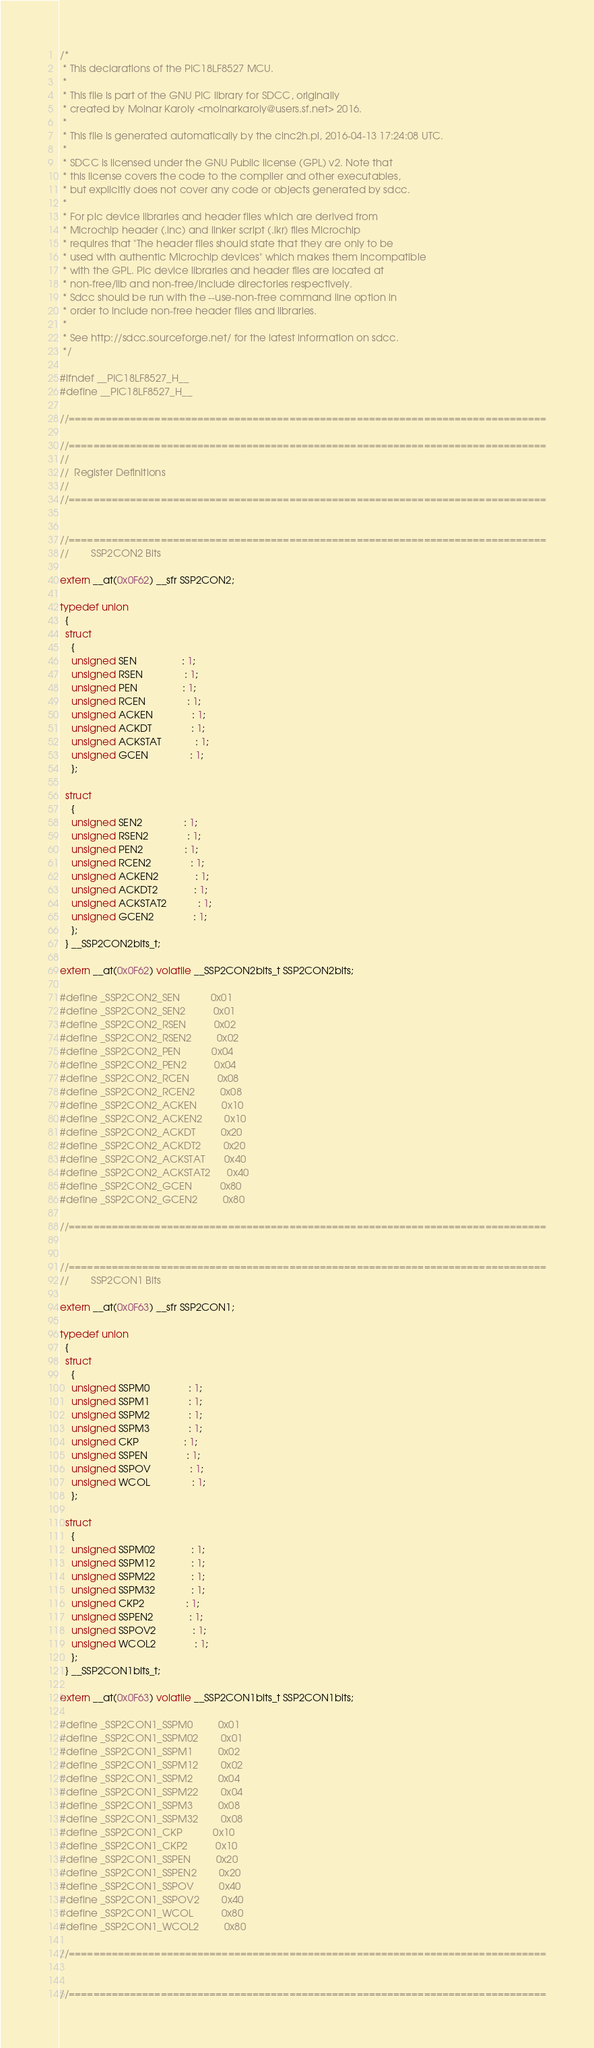Convert code to text. <code><loc_0><loc_0><loc_500><loc_500><_C_>/*
 * This declarations of the PIC18LF8527 MCU.
 *
 * This file is part of the GNU PIC library for SDCC, originally
 * created by Molnar Karoly <molnarkaroly@users.sf.net> 2016.
 *
 * This file is generated automatically by the cinc2h.pl, 2016-04-13 17:24:08 UTC.
 *
 * SDCC is licensed under the GNU Public license (GPL) v2. Note that
 * this license covers the code to the compiler and other executables,
 * but explicitly does not cover any code or objects generated by sdcc.
 *
 * For pic device libraries and header files which are derived from
 * Microchip header (.inc) and linker script (.lkr) files Microchip
 * requires that "The header files should state that they are only to be
 * used with authentic Microchip devices" which makes them incompatible
 * with the GPL. Pic device libraries and header files are located at
 * non-free/lib and non-free/include directories respectively.
 * Sdcc should be run with the --use-non-free command line option in
 * order to include non-free header files and libraries.
 *
 * See http://sdcc.sourceforge.net/ for the latest information on sdcc.
 */

#ifndef __PIC18LF8527_H__
#define __PIC18LF8527_H__

//==============================================================================

//==============================================================================
//
//	Register Definitions
//
//==============================================================================


//==============================================================================
//        SSP2CON2 Bits

extern __at(0x0F62) __sfr SSP2CON2;

typedef union
  {
  struct
    {
    unsigned SEN                : 1;
    unsigned RSEN               : 1;
    unsigned PEN                : 1;
    unsigned RCEN               : 1;
    unsigned ACKEN              : 1;
    unsigned ACKDT              : 1;
    unsigned ACKSTAT            : 1;
    unsigned GCEN               : 1;
    };

  struct
    {
    unsigned SEN2               : 1;
    unsigned RSEN2              : 1;
    unsigned PEN2               : 1;
    unsigned RCEN2              : 1;
    unsigned ACKEN2             : 1;
    unsigned ACKDT2             : 1;
    unsigned ACKSTAT2           : 1;
    unsigned GCEN2              : 1;
    };
  } __SSP2CON2bits_t;

extern __at(0x0F62) volatile __SSP2CON2bits_t SSP2CON2bits;

#define _SSP2CON2_SEN           0x01
#define _SSP2CON2_SEN2          0x01
#define _SSP2CON2_RSEN          0x02
#define _SSP2CON2_RSEN2         0x02
#define _SSP2CON2_PEN           0x04
#define _SSP2CON2_PEN2          0x04
#define _SSP2CON2_RCEN          0x08
#define _SSP2CON2_RCEN2         0x08
#define _SSP2CON2_ACKEN         0x10
#define _SSP2CON2_ACKEN2        0x10
#define _SSP2CON2_ACKDT         0x20
#define _SSP2CON2_ACKDT2        0x20
#define _SSP2CON2_ACKSTAT       0x40
#define _SSP2CON2_ACKSTAT2      0x40
#define _SSP2CON2_GCEN          0x80
#define _SSP2CON2_GCEN2         0x80

//==============================================================================


//==============================================================================
//        SSP2CON1 Bits

extern __at(0x0F63) __sfr SSP2CON1;

typedef union
  {
  struct
    {
    unsigned SSPM0              : 1;
    unsigned SSPM1              : 1;
    unsigned SSPM2              : 1;
    unsigned SSPM3              : 1;
    unsigned CKP                : 1;
    unsigned SSPEN              : 1;
    unsigned SSPOV              : 1;
    unsigned WCOL               : 1;
    };

  struct
    {
    unsigned SSPM02             : 1;
    unsigned SSPM12             : 1;
    unsigned SSPM22             : 1;
    unsigned SSPM32             : 1;
    unsigned CKP2               : 1;
    unsigned SSPEN2             : 1;
    unsigned SSPOV2             : 1;
    unsigned WCOL2              : 1;
    };
  } __SSP2CON1bits_t;

extern __at(0x0F63) volatile __SSP2CON1bits_t SSP2CON1bits;

#define _SSP2CON1_SSPM0         0x01
#define _SSP2CON1_SSPM02        0x01
#define _SSP2CON1_SSPM1         0x02
#define _SSP2CON1_SSPM12        0x02
#define _SSP2CON1_SSPM2         0x04
#define _SSP2CON1_SSPM22        0x04
#define _SSP2CON1_SSPM3         0x08
#define _SSP2CON1_SSPM32        0x08
#define _SSP2CON1_CKP           0x10
#define _SSP2CON1_CKP2          0x10
#define _SSP2CON1_SSPEN         0x20
#define _SSP2CON1_SSPEN2        0x20
#define _SSP2CON1_SSPOV         0x40
#define _SSP2CON1_SSPOV2        0x40
#define _SSP2CON1_WCOL          0x80
#define _SSP2CON1_WCOL2         0x80

//==============================================================================


//==============================================================================</code> 